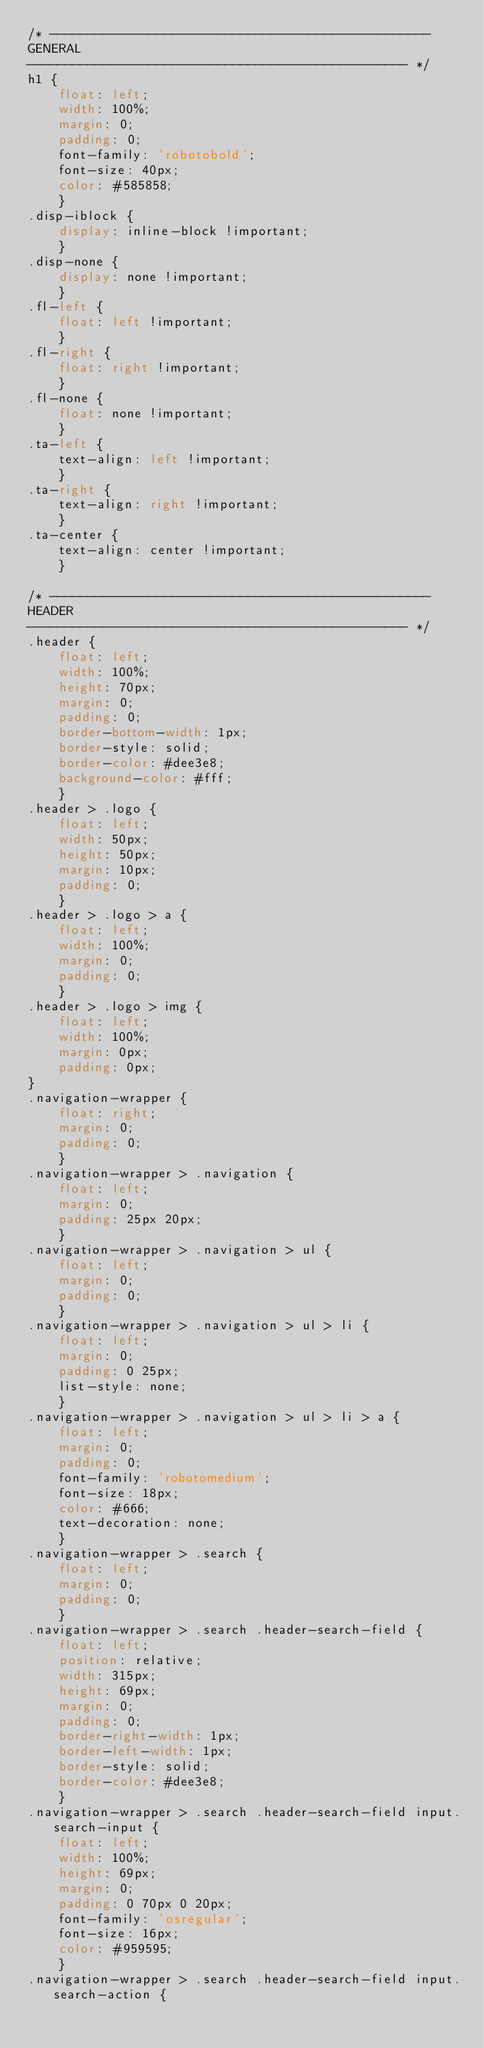<code> <loc_0><loc_0><loc_500><loc_500><_CSS_>/* --------------------------------------------------
GENERAL
-------------------------------------------------- */
h1 {
	float: left;
	width: 100%;
	margin: 0;
	padding: 0;
	font-family: 'robotobold';
	font-size: 40px;
	color: #585858;
	}
.disp-iblock {
	display: inline-block !important;
	}
.disp-none {
	display: none !important;
	}
.fl-left {
	float: left !important;
	}
.fl-right {
	float: right !important;
	}
.fl-none {
	float: none !important;
	}
.ta-left {
	text-align: left !important;
	}
.ta-right {
	text-align: right !important;
	}
.ta-center {
	text-align: center !important;
	}

/* --------------------------------------------------
HEADER
-------------------------------------------------- */
.header {
	float: left;
	width: 100%;
	height: 70px;
	margin: 0;
	padding: 0;
	border-bottom-width: 1px;
	border-style: solid;
	border-color: #dee3e8;
	background-color: #fff;
	}
.header > .logo {
	float: left;
	width: 50px;
	height: 50px;
	margin: 10px;
	padding: 0;
	}
.header > .logo > a {
	float: left;
	width: 100%;
	margin: 0;
	padding: 0;
	}
.header > .logo > img {
	float: left;
	width: 100%;
	margin: 0px;
	padding: 0px;
}
.navigation-wrapper {
	float: right;
	margin: 0;
	padding: 0;
	}
.navigation-wrapper > .navigation {
	float: left;
	margin: 0;
	padding: 25px 20px;
	}
.navigation-wrapper > .navigation > ul {
	float: left;
	margin: 0;
	padding: 0;
	}
.navigation-wrapper > .navigation > ul > li {
	float: left;
	margin: 0;
	padding: 0 25px;
	list-style: none;
	}
.navigation-wrapper > .navigation > ul > li > a {
	float: left;
	margin: 0;
	padding: 0;
	font-family: 'robotomedium';
	font-size: 18px;
	color: #666;
	text-decoration: none;
	}
.navigation-wrapper > .search {
	float: left;
	margin: 0;
	padding: 0;
	}
.navigation-wrapper > .search .header-search-field {
	float: left;
	position: relative;
	width: 315px;
	height: 69px;
	margin: 0;
	padding: 0;
	border-right-width: 1px;
	border-left-width: 1px;
	border-style: solid;
	border-color: #dee3e8;
	}
.navigation-wrapper > .search .header-search-field input.search-input {
	float: left;
	width: 100%;
	height: 69px;
	margin: 0;
	padding: 0 70px 0 20px;
	font-family: 'osregular';
	font-size: 16px;
	color: #959595;
	}
.navigation-wrapper > .search .header-search-field input.search-action {</code> 